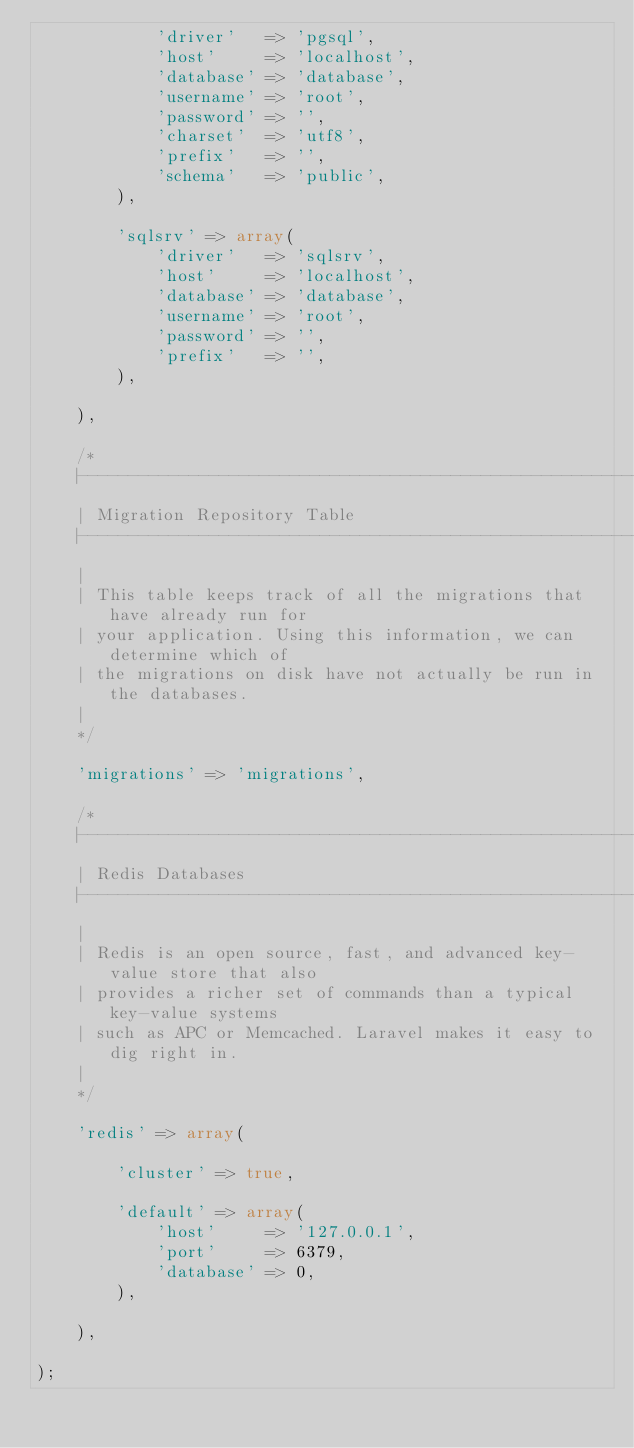<code> <loc_0><loc_0><loc_500><loc_500><_PHP_>			'driver'   => 'pgsql',
			'host'     => 'localhost',
			'database' => 'database',
			'username' => 'root',
			'password' => '',
			'charset'  => 'utf8',
			'prefix'   => '',
			'schema'   => 'public',
		),

		'sqlsrv' => array(
			'driver'   => 'sqlsrv',
			'host'     => 'localhost',
			'database' => 'database',
			'username' => 'root',
			'password' => '',
			'prefix'   => '',
		),

	),

	/*
	|--------------------------------------------------------------------------
	| Migration Repository Table
	|--------------------------------------------------------------------------
	|
	| This table keeps track of all the migrations that have already run for
	| your application. Using this information, we can determine which of
	| the migrations on disk have not actually be run in the databases.
	|
	*/

	'migrations' => 'migrations',

	/*
	|--------------------------------------------------------------------------
	| Redis Databases
	|--------------------------------------------------------------------------
	|
	| Redis is an open source, fast, and advanced key-value store that also
	| provides a richer set of commands than a typical key-value systems
	| such as APC or Memcached. Laravel makes it easy to dig right in.
	|
	*/

	'redis' => array(

		'cluster' => true,

		'default' => array(
			'host'     => '127.0.0.1',
			'port'     => 6379,
			'database' => 0,
		),

	),

);</code> 